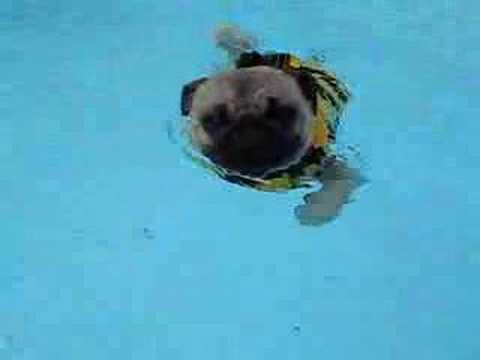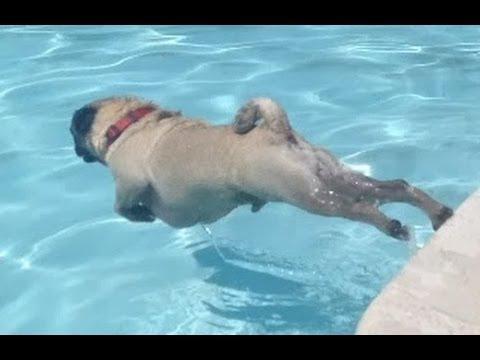The first image is the image on the left, the second image is the image on the right. Given the left and right images, does the statement "Only one pug is wearing a life vest." hold true? Answer yes or no. Yes. The first image is the image on the left, the second image is the image on the right. Evaluate the accuracy of this statement regarding the images: "The pug in the left image is wearing a swimming vest.". Is it true? Answer yes or no. Yes. 